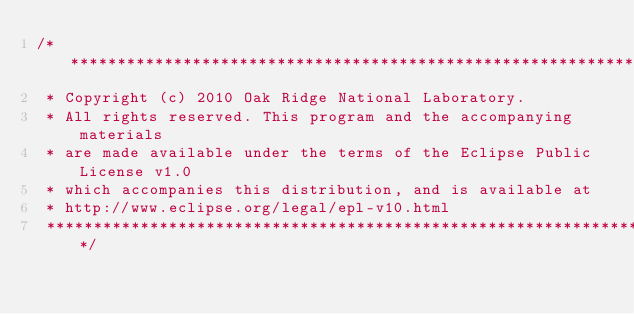Convert code to text. <code><loc_0><loc_0><loc_500><loc_500><_Java_>/*******************************************************************************
 * Copyright (c) 2010 Oak Ridge National Laboratory.
 * All rights reserved. This program and the accompanying materials
 * are made available under the terms of the Eclipse Public License v1.0
 * which accompanies this distribution, and is available at
 * http://www.eclipse.org/legal/epl-v10.html
 ******************************************************************************/</code> 